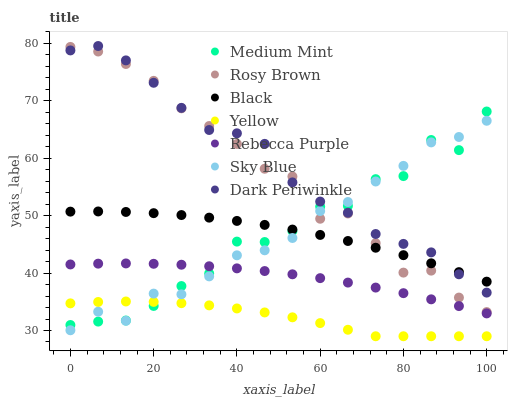Does Yellow have the minimum area under the curve?
Answer yes or no. Yes. Does Dark Periwinkle have the maximum area under the curve?
Answer yes or no. Yes. Does Rosy Brown have the minimum area under the curve?
Answer yes or no. No. Does Rosy Brown have the maximum area under the curve?
Answer yes or no. No. Is Rebecca Purple the smoothest?
Answer yes or no. Yes. Is Medium Mint the roughest?
Answer yes or no. Yes. Is Rosy Brown the smoothest?
Answer yes or no. No. Is Rosy Brown the roughest?
Answer yes or no. No. Does Yellow have the lowest value?
Answer yes or no. Yes. Does Rosy Brown have the lowest value?
Answer yes or no. No. Does Dark Periwinkle have the highest value?
Answer yes or no. Yes. Does Rosy Brown have the highest value?
Answer yes or no. No. Is Yellow less than Rosy Brown?
Answer yes or no. Yes. Is Black greater than Yellow?
Answer yes or no. Yes. Does Yellow intersect Sky Blue?
Answer yes or no. Yes. Is Yellow less than Sky Blue?
Answer yes or no. No. Is Yellow greater than Sky Blue?
Answer yes or no. No. Does Yellow intersect Rosy Brown?
Answer yes or no. No. 